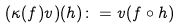<formula> <loc_0><loc_0><loc_500><loc_500>( \kappa ( f ) v ) ( h ) \colon = v ( f \circ h )</formula> 